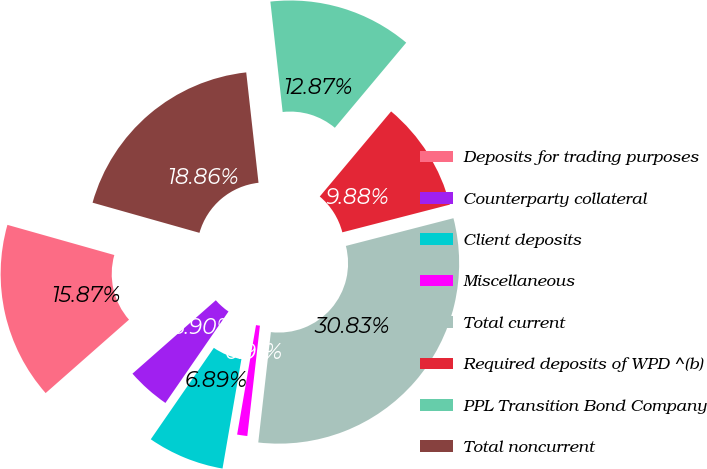Convert chart to OTSL. <chart><loc_0><loc_0><loc_500><loc_500><pie_chart><fcel>Deposits for trading purposes<fcel>Counterparty collateral<fcel>Client deposits<fcel>Miscellaneous<fcel>Total current<fcel>Required deposits of WPD ^(b)<fcel>PPL Transition Bond Company<fcel>Total noncurrent<nl><fcel>15.87%<fcel>3.9%<fcel>6.89%<fcel>0.91%<fcel>30.83%<fcel>9.88%<fcel>12.87%<fcel>18.86%<nl></chart> 